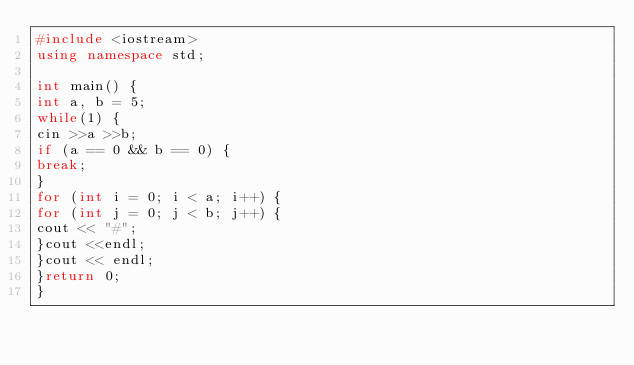Convert code to text. <code><loc_0><loc_0><loc_500><loc_500><_C++_>#include <iostream>
using namespace std;

int main() {
int a, b = 5;
while(1) {
cin >>a >>b;
if (a == 0 && b == 0) {
break;
}
for (int i = 0; i < a; i++) {
for (int j = 0; j < b; j++) {
cout << "#";
}cout <<endl;
}cout << endl;
}return 0;
}


</code> 